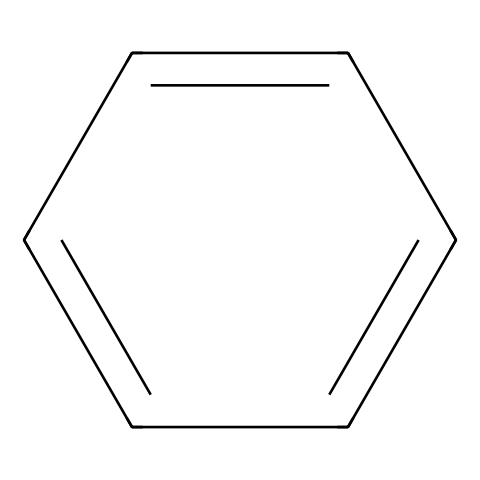What is the name of the chemical represented here? The SMILES structure provided corresponds to the formula for benzene, which is a well-known aromatic hydrocarbon. It consists of a cyclic arrangement of carbon atoms with alternating double bonds.
Answer: benzene How many carbon atoms are in this chemical? The SMILES notation indicates that there are six 'c' (carbon) atoms in a ring, confirming that there are six carbon atoms in the structure of benzene.
Answer: 6 What type of bonding is present in this chemical? Benzene is characterized by alternating single and double bonds due to its resonance structure, implying that it has both sigma and pi bonds between the carbon atoms.
Answer: sigma and pi bonds What is the degree of saturation of benzene? Benzene, with its structure, exhibits a high level of saturation where the degree of saturation calculated for a cyclic alkene with six carbons and six hydrogens fulfills the criteria for an aromatic compound.
Answer: 4 What is the primary functional group in benzene? The structure of benzene without any substituents consists purely of hydrocarbons; therefore, it does not have any functional group present as it stands.
Answer: none How does the structure of benzene relate to indoor air quality? Benzene is known as an indoor air pollutant primarily due to its volatility and presence in various industrial products, which can evaporate and contaminate the air in office environments.
Answer: volatile organic compound 